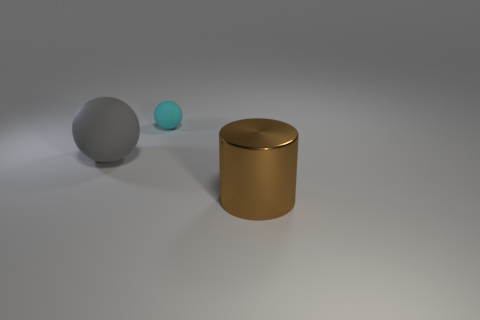Add 3 tiny matte balls. How many objects exist? 6 Subtract all balls. How many objects are left? 1 Subtract all cyan blocks. How many cyan balls are left? 1 Subtract all big gray spheres. Subtract all gray spheres. How many objects are left? 1 Add 2 big brown cylinders. How many big brown cylinders are left? 3 Add 1 big rubber objects. How many big rubber objects exist? 2 Subtract 0 red blocks. How many objects are left? 3 Subtract all brown balls. Subtract all gray cylinders. How many balls are left? 2 